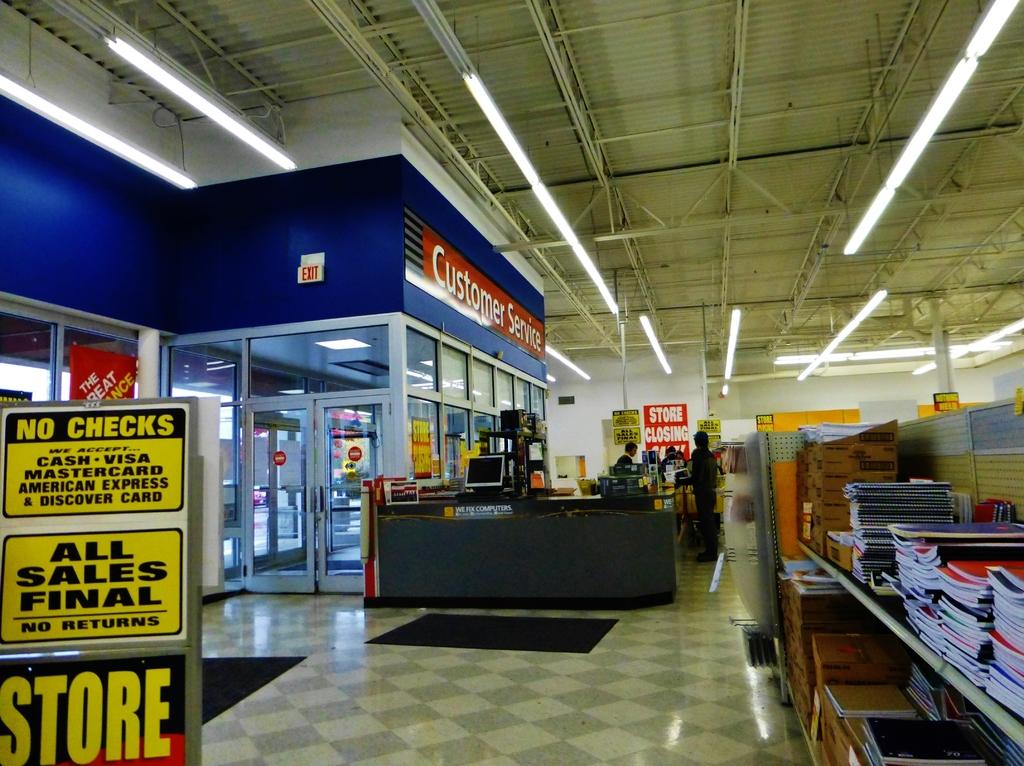What is their return policy at this store?
Offer a terse response. No returns. What is written on top of the storefront?
Your answer should be compact. Customer service. 